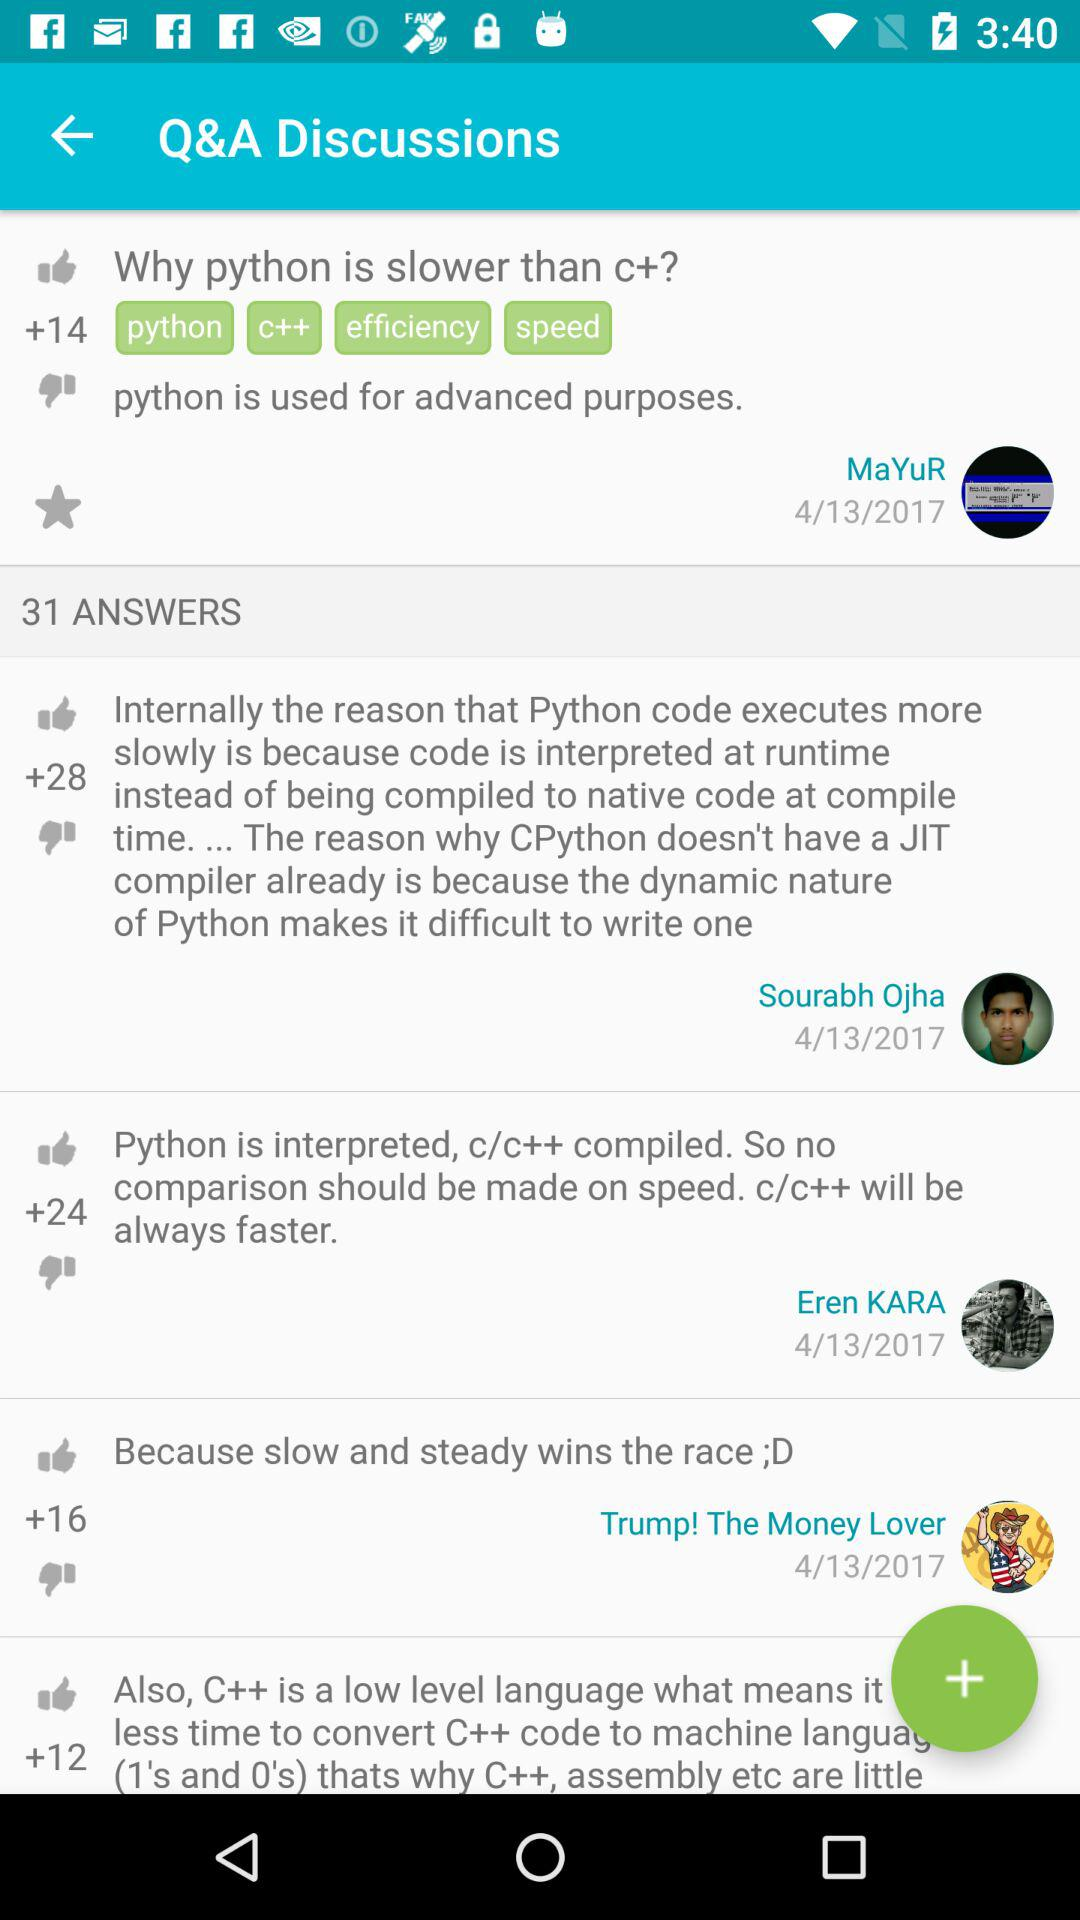How many thumbs up does the answer with the most thumbs up have?
Answer the question using a single word or phrase. 28 